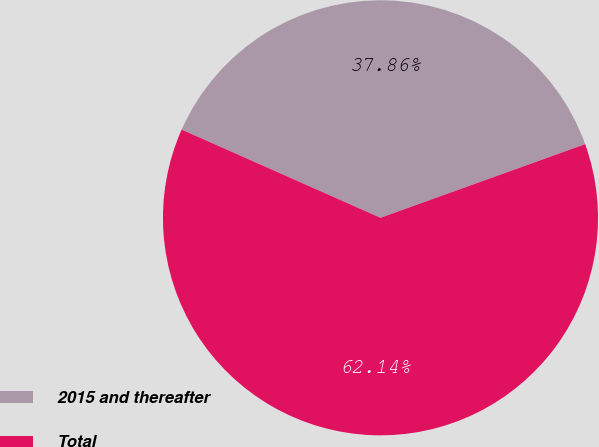<chart> <loc_0><loc_0><loc_500><loc_500><pie_chart><fcel>2015 and thereafter<fcel>Total<nl><fcel>37.86%<fcel>62.14%<nl></chart> 